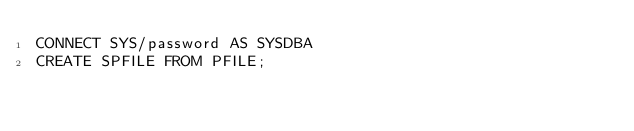<code> <loc_0><loc_0><loc_500><loc_500><_SQL_>CONNECT SYS/password AS SYSDBA
CREATE SPFILE FROM PFILE;
</code> 